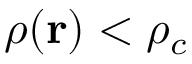<formula> <loc_0><loc_0><loc_500><loc_500>\rho ( r ) < \rho _ { c }</formula> 